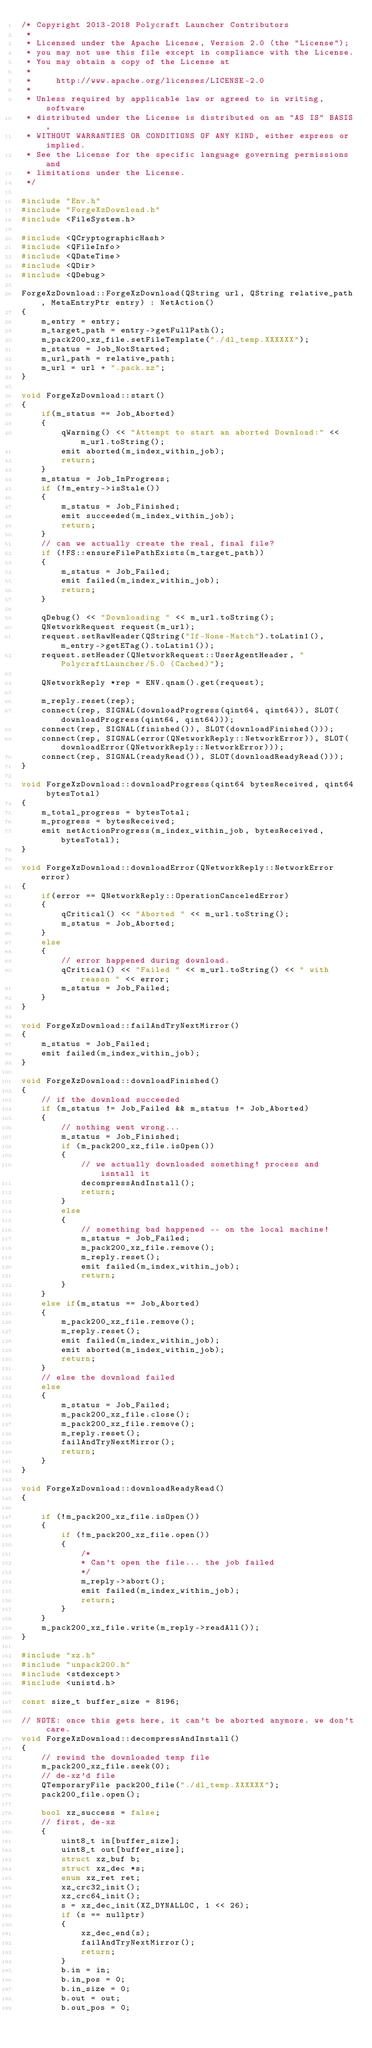<code> <loc_0><loc_0><loc_500><loc_500><_C++_>/* Copyright 2013-2018 Polycraft Launcher Contributors
 *
 * Licensed under the Apache License, Version 2.0 (the "License");
 * you may not use this file except in compliance with the License.
 * You may obtain a copy of the License at
 *
 *     http://www.apache.org/licenses/LICENSE-2.0
 *
 * Unless required by applicable law or agreed to in writing, software
 * distributed under the License is distributed on an "AS IS" BASIS,
 * WITHOUT WARRANTIES OR CONDITIONS OF ANY KIND, either express or implied.
 * See the License for the specific language governing permissions and
 * limitations under the License.
 */

#include "Env.h"
#include "ForgeXzDownload.h"
#include <FileSystem.h>

#include <QCryptographicHash>
#include <QFileInfo>
#include <QDateTime>
#include <QDir>
#include <QDebug>

ForgeXzDownload::ForgeXzDownload(QString url, QString relative_path, MetaEntryPtr entry) : NetAction()
{
    m_entry = entry;
    m_target_path = entry->getFullPath();
    m_pack200_xz_file.setFileTemplate("./dl_temp.XXXXXX");
    m_status = Job_NotStarted;
    m_url_path = relative_path;
    m_url = url + ".pack.xz";
}

void ForgeXzDownload::start()
{
    if(m_status == Job_Aborted)
    {
        qWarning() << "Attempt to start an aborted Download:" << m_url.toString();
        emit aborted(m_index_within_job);
        return;
    }
    m_status = Job_InProgress;
    if (!m_entry->isStale())
    {
        m_status = Job_Finished;
        emit succeeded(m_index_within_job);
        return;
    }
    // can we actually create the real, final file?
    if (!FS::ensureFilePathExists(m_target_path))
    {
        m_status = Job_Failed;
        emit failed(m_index_within_job);
        return;
    }

    qDebug() << "Downloading " << m_url.toString();
    QNetworkRequest request(m_url);
    request.setRawHeader(QString("If-None-Match").toLatin1(), m_entry->getETag().toLatin1());
    request.setHeader(QNetworkRequest::UserAgentHeader, "PolycraftLauncher/5.0 (Cached)");

    QNetworkReply *rep = ENV.qnam().get(request);

    m_reply.reset(rep);
    connect(rep, SIGNAL(downloadProgress(qint64, qint64)), SLOT(downloadProgress(qint64, qint64)));
    connect(rep, SIGNAL(finished()), SLOT(downloadFinished()));
    connect(rep, SIGNAL(error(QNetworkReply::NetworkError)), SLOT(downloadError(QNetworkReply::NetworkError)));
    connect(rep, SIGNAL(readyRead()), SLOT(downloadReadyRead()));
}

void ForgeXzDownload::downloadProgress(qint64 bytesReceived, qint64 bytesTotal)
{
    m_total_progress = bytesTotal;
    m_progress = bytesReceived;
    emit netActionProgress(m_index_within_job, bytesReceived, bytesTotal);
}

void ForgeXzDownload::downloadError(QNetworkReply::NetworkError error)
{
    if(error == QNetworkReply::OperationCanceledError)
    {
        qCritical() << "Aborted " << m_url.toString();
        m_status = Job_Aborted;
    }
    else
    {
        // error happened during download.
        qCritical() << "Failed " << m_url.toString() << " with reason " << error;
        m_status = Job_Failed;
    }
}

void ForgeXzDownload::failAndTryNextMirror()
{
    m_status = Job_Failed;
    emit failed(m_index_within_job);
}

void ForgeXzDownload::downloadFinished()
{
    // if the download succeeded
    if (m_status != Job_Failed && m_status != Job_Aborted)
    {
        // nothing went wrong...
        m_status = Job_Finished;
        if (m_pack200_xz_file.isOpen())
        {
            // we actually downloaded something! process and isntall it
            decompressAndInstall();
            return;
        }
        else
        {
            // something bad happened -- on the local machine!
            m_status = Job_Failed;
            m_pack200_xz_file.remove();
            m_reply.reset();
            emit failed(m_index_within_job);
            return;
        }
    }
    else if(m_status == Job_Aborted)
    {
        m_pack200_xz_file.remove();
        m_reply.reset();
        emit failed(m_index_within_job);
        emit aborted(m_index_within_job);
        return;
    }
    // else the download failed
    else
    {
        m_status = Job_Failed;
        m_pack200_xz_file.close();
        m_pack200_xz_file.remove();
        m_reply.reset();
        failAndTryNextMirror();
        return;
    }
}

void ForgeXzDownload::downloadReadyRead()
{

    if (!m_pack200_xz_file.isOpen())
    {
        if (!m_pack200_xz_file.open())
        {
            /*
            * Can't open the file... the job failed
            */
            m_reply->abort();
            emit failed(m_index_within_job);
            return;
        }
    }
    m_pack200_xz_file.write(m_reply->readAll());
}

#include "xz.h"
#include "unpack200.h"
#include <stdexcept>
#include <unistd.h>

const size_t buffer_size = 8196;

// NOTE: once this gets here, it can't be aborted anymore. we don't care.
void ForgeXzDownload::decompressAndInstall()
{
    // rewind the downloaded temp file
    m_pack200_xz_file.seek(0);
    // de-xz'd file
    QTemporaryFile pack200_file("./dl_temp.XXXXXX");
    pack200_file.open();

    bool xz_success = false;
    // first, de-xz
    {
        uint8_t in[buffer_size];
        uint8_t out[buffer_size];
        struct xz_buf b;
        struct xz_dec *s;
        enum xz_ret ret;
        xz_crc32_init();
        xz_crc64_init();
        s = xz_dec_init(XZ_DYNALLOC, 1 << 26);
        if (s == nullptr)
        {
            xz_dec_end(s);
            failAndTryNextMirror();
            return;
        }
        b.in = in;
        b.in_pos = 0;
        b.in_size = 0;
        b.out = out;
        b.out_pos = 0;</code> 